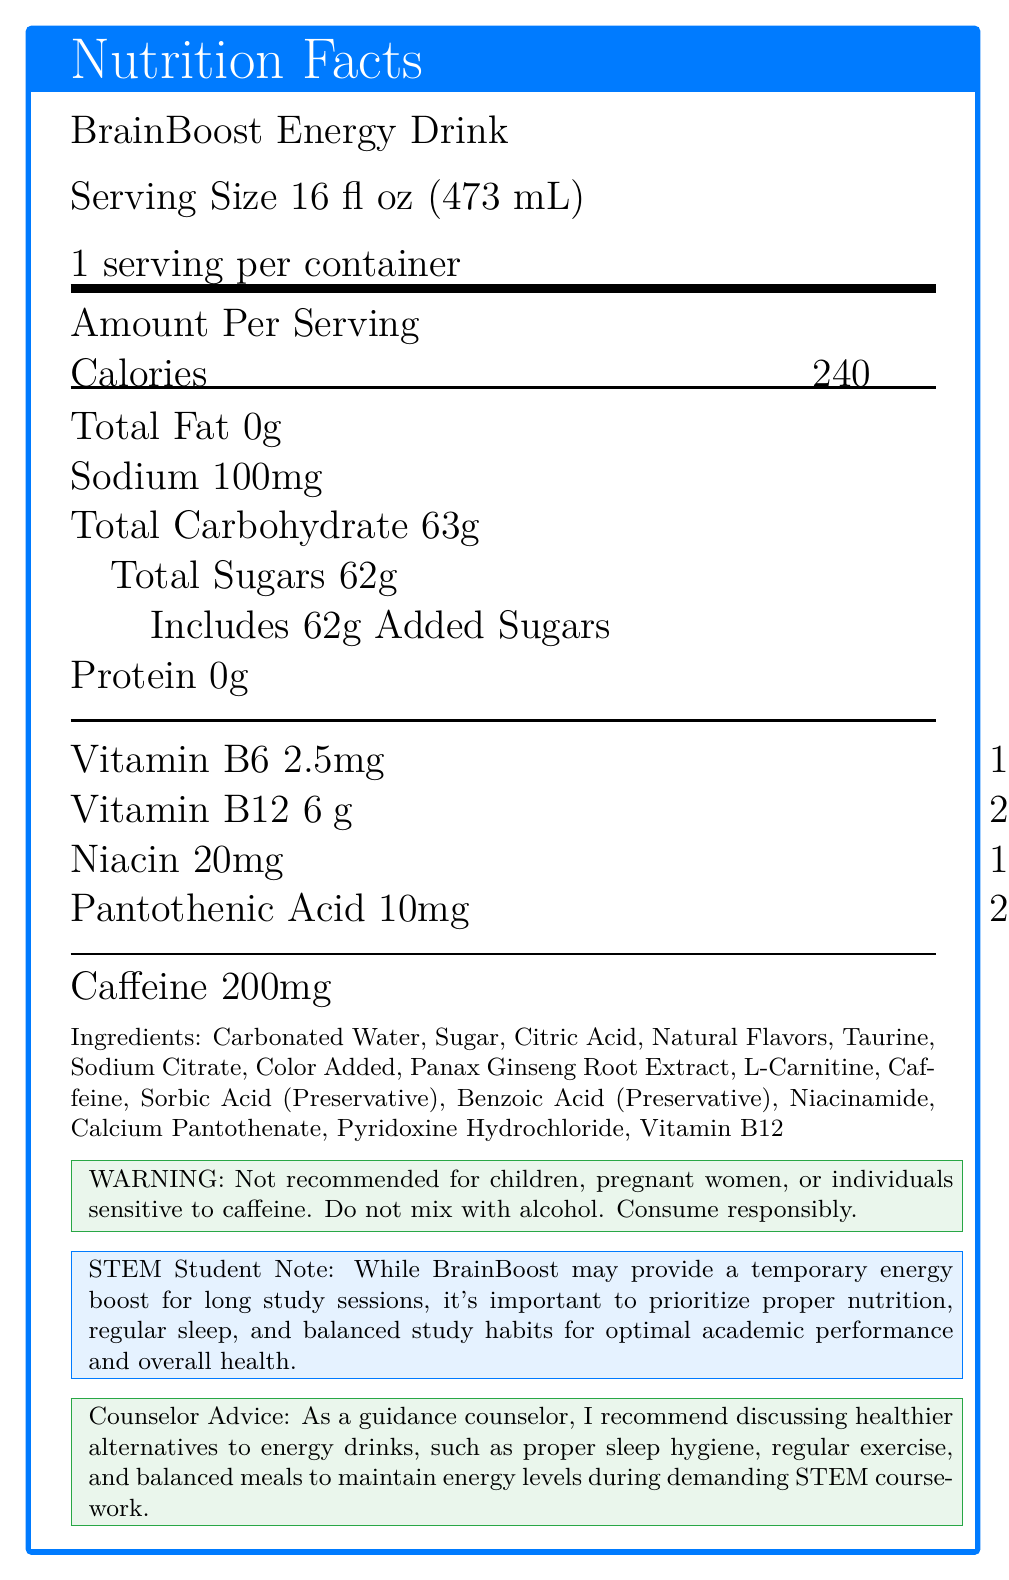what is the serving size of BrainBoost Energy Drink? The serving size is explicitly mentioned as "Serving Size 16 fl oz (473 mL)" in the document.
Answer: 16 fl oz (473 mL) how many calories are in one serving of BrainBoost Energy Drink? The amount of calories per serving is stated as "Calories 240".
Answer: 240 how much caffeine is in BrainBoost Energy Drink? The caffeine content is listed as "Caffeine 200mg".
Answer: 200mg what percentage of the daily value of sodium does one serving of BrainBoost contain? The sodium content percentage of the daily value is listed as "Sodium 100mg, 4%".
Answer: 4% how much total sugar does BrainBoost Energy Drink contain, and how much of it is added sugars? The document specifies "Total Sugars 62g" and "Includes 62g Added Sugars".
Answer: 62g total sugar, 62g added sugar which vitamin has the highest daily value percentage in BrainBoost Energy Drink? A. Vitamin B6 B. Vitamin B12 C. Niacin D. Pantothenic Acid The document lists "Vitamin B12 250%" which is the highest daily value percentage.
Answer: B. Vitamin B12 how many servings are there per container? A. 1 B. 2 C. 3 D. 4 The document states "1 serving per container".
Answer: A. 1 is BrainBoost Energy Drink suitable for children and pregnant women? The warning section clearly states "Not recommended for children, pregnant women, or individuals sensitive to caffeine".
Answer: No what is the primary message in the counselor advice section? The counselor advice suggests discussing healthier alternatives like proper sleep hygiene, regular exercise, and balanced meals.
Answer: Discuss healthier alternatives to energy drinks who should avoid consuming BrainBoost Energy Drink? The warning section specifies these groups as those who should avoid the drink.
Answer: Children, pregnant women, individuals sensitive to caffeine how does the document suggest STEM students maintain energy levels? The "STEM Student Note" advises these practices for maintaining energy levels.
Answer: Proper nutrition, regular sleep, balanced study habits can BrainBoost Energy Drink be mixed with alcohol according to the document? The warning states "Do not mix with alcohol".
Answer: No summarize the main points of the BrainBoost Energy Drink Nutrition Facts Label. The document provides detailed nutritional information about the BrainBoost Energy Drink, emphasizes high sugar and caffeine content, and includes warnings and advice on healthier lifestyle choices.
Answer: BrainBoost Energy Drink contains 240 calories, 0g fat, 100mg sodium, 63g carbohydrates (including 62g of sugar), and 0g protein per serving. It also contains high levels of vitamins B6, B12, niacin, and pantothenic acid. The drink has 200mg of caffeine and is not recommended for children, pregnant women, or people sensitive to caffeine. The document emphasizes healthier alternatives and balanced habits for STEM students. how much L-Carnitine is present in BrainBoost Energy Drink? The document lists L-Carnitine as an ingredient but does not specify the amount.
Answer: Not enough information is the drink high in added sugars? True or False The drink contains "62g Added Sugars" which is 124% of the daily value, indicating a high amount of added sugars.
Answer: True 